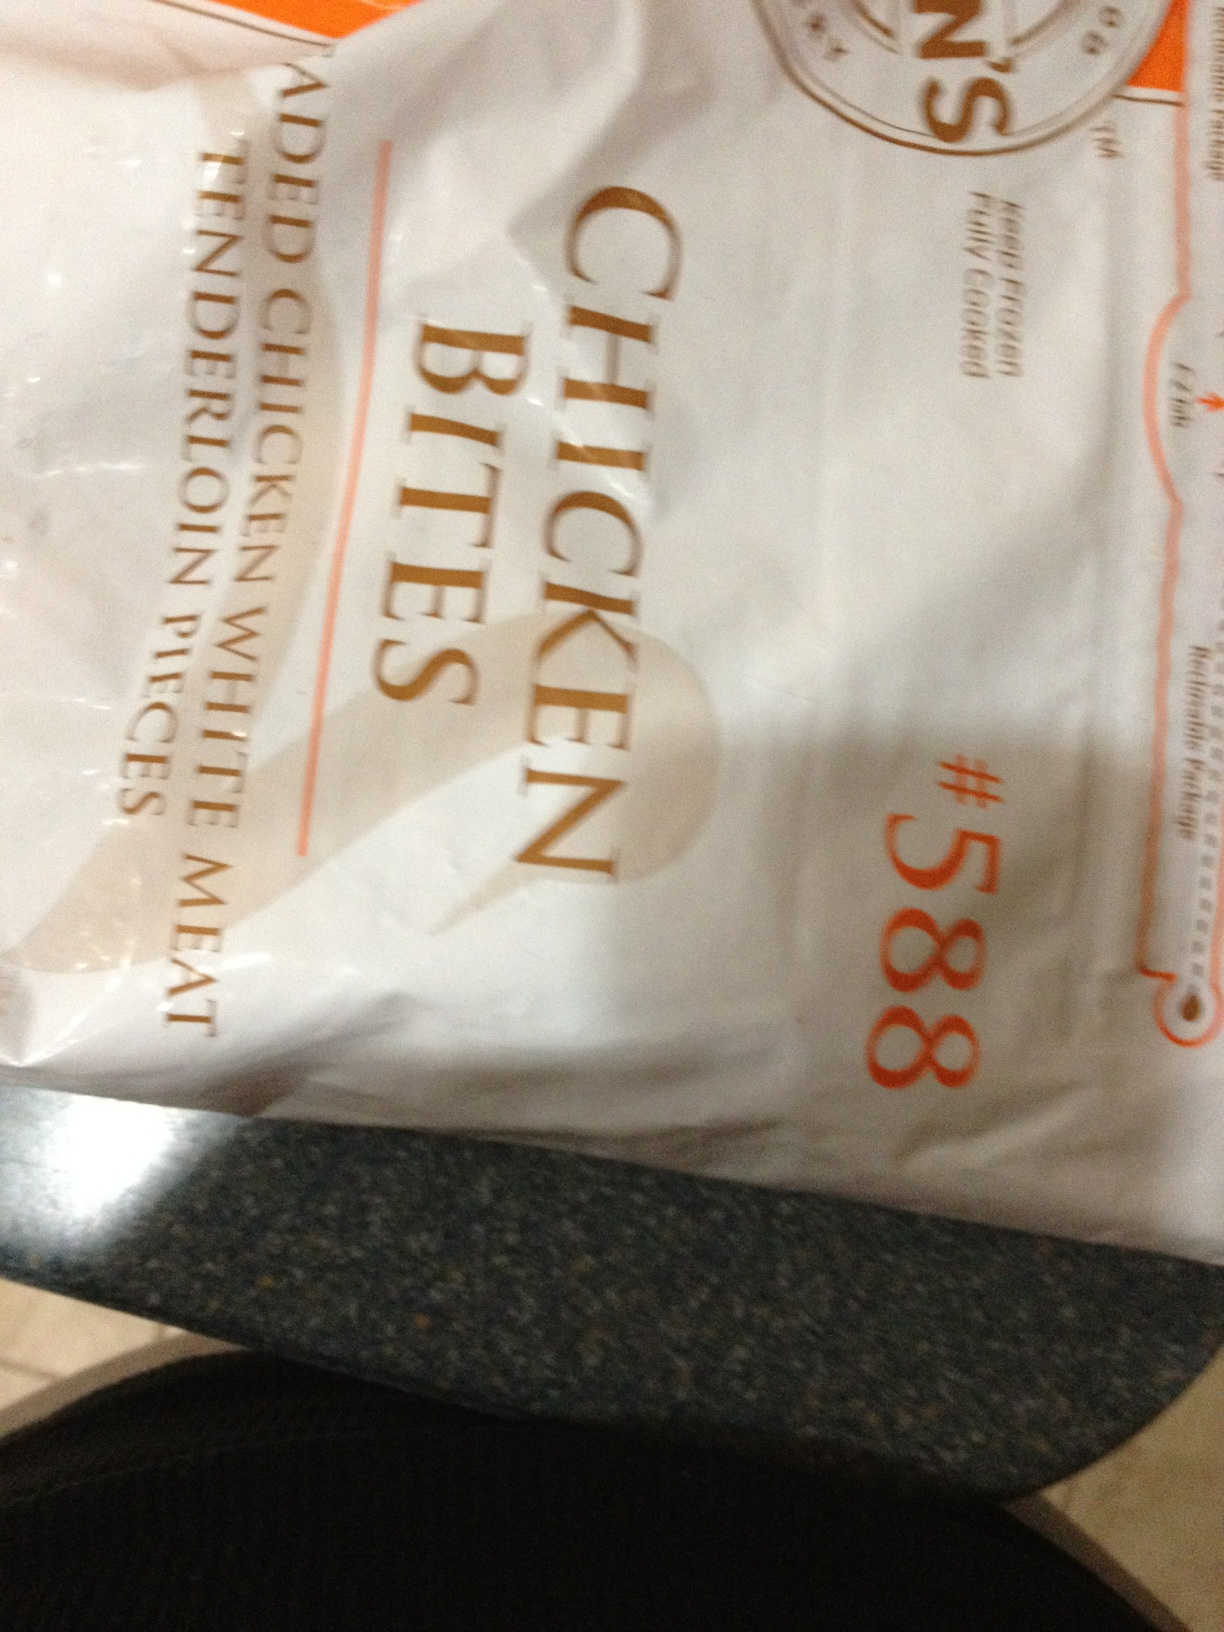What is this? This is a package of chicken bites, specifically marked as item number 588, which likely refers to a product or batch code. These are made from added chicken tenderloin with rice meat, suggesting they are processed chicken pieces intended for quick cooking and consumption. 